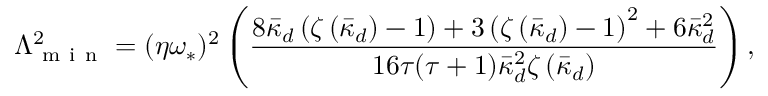<formula> <loc_0><loc_0><loc_500><loc_500>\Lambda _ { m i n } ^ { 2 } = ( \eta \omega _ { \ast } ) ^ { 2 } \left ( \frac { 8 \bar { \kappa } _ { d } \left ( \zeta \left ( \bar { \kappa } _ { d } \right ) - 1 \right ) + 3 \left ( \zeta \left ( \bar { \kappa } _ { d } \right ) - 1 \right ) ^ { 2 } + 6 \bar { \kappa } _ { d } ^ { 2 } } { 1 6 \tau ( \tau + 1 ) \bar { \kappa } _ { d } ^ { 2 } \zeta \left ( \bar { \kappa } _ { d } \right ) } \right ) ,</formula> 